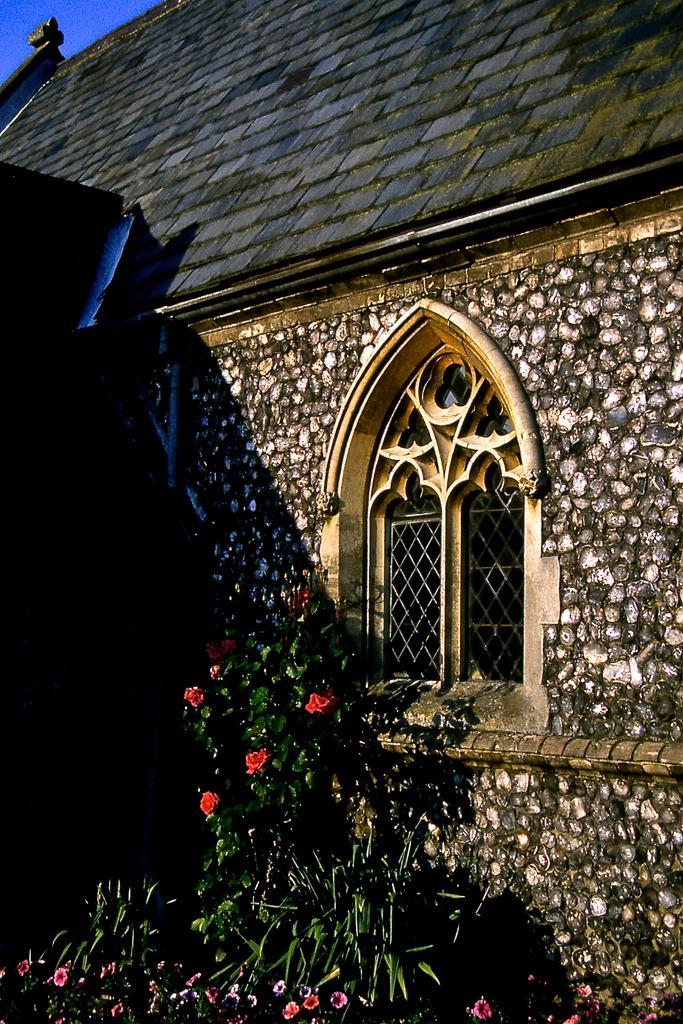Describe this image in one or two sentences. We can see plants,flowers,window and roof top. 